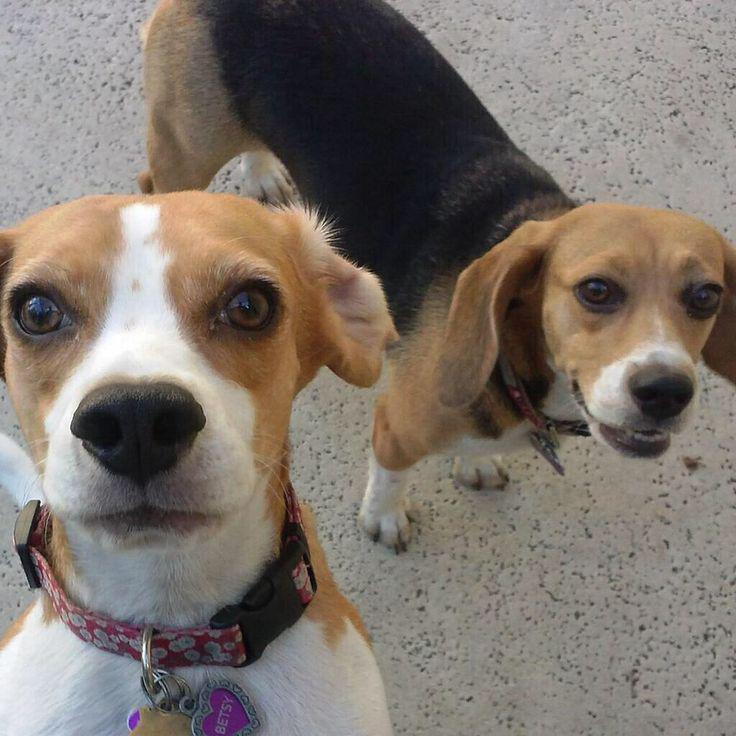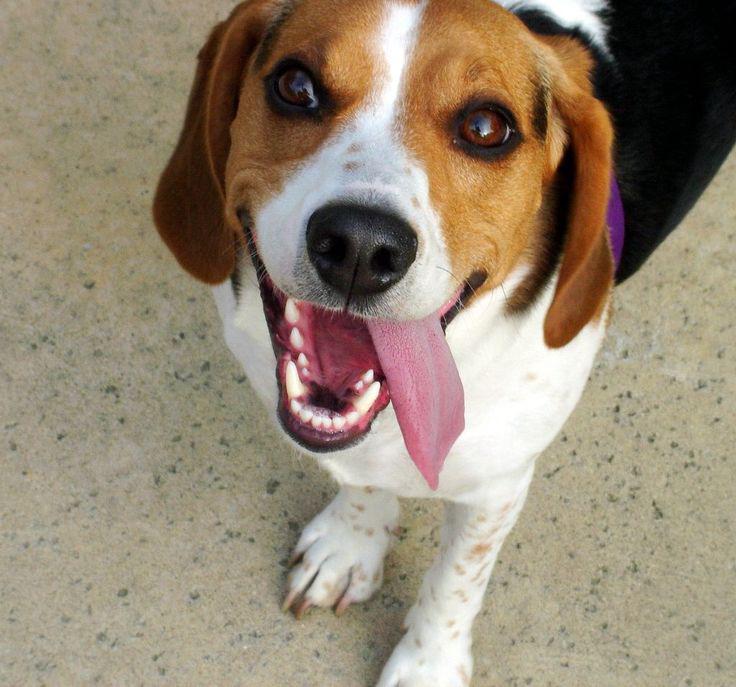The first image is the image on the left, the second image is the image on the right. Assess this claim about the two images: "All dogs are looking up at the camera, at least one dog has an open mouth, and no image contains more than two dogs.". Correct or not? Answer yes or no. Yes. The first image is the image on the left, the second image is the image on the right. Analyze the images presented: Is the assertion "There are at least two dogs in the left image." valid? Answer yes or no. Yes. 